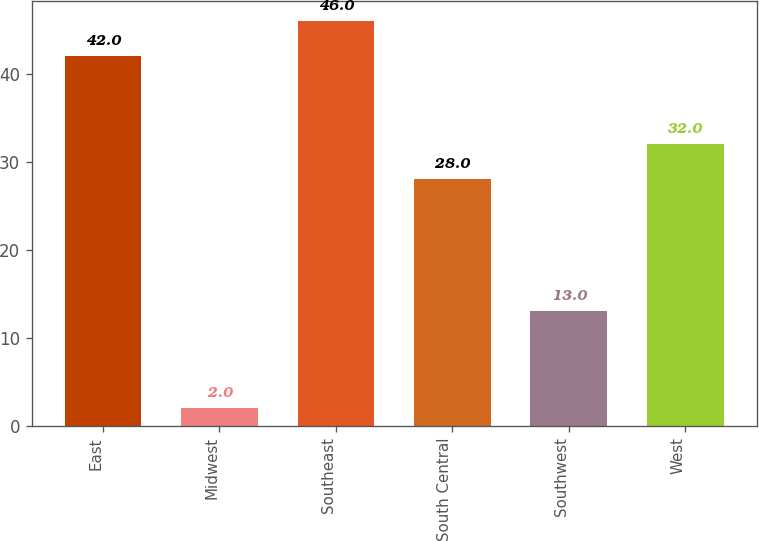Convert chart. <chart><loc_0><loc_0><loc_500><loc_500><bar_chart><fcel>East<fcel>Midwest<fcel>Southeast<fcel>South Central<fcel>Southwest<fcel>West<nl><fcel>42<fcel>2<fcel>46<fcel>28<fcel>13<fcel>32<nl></chart> 